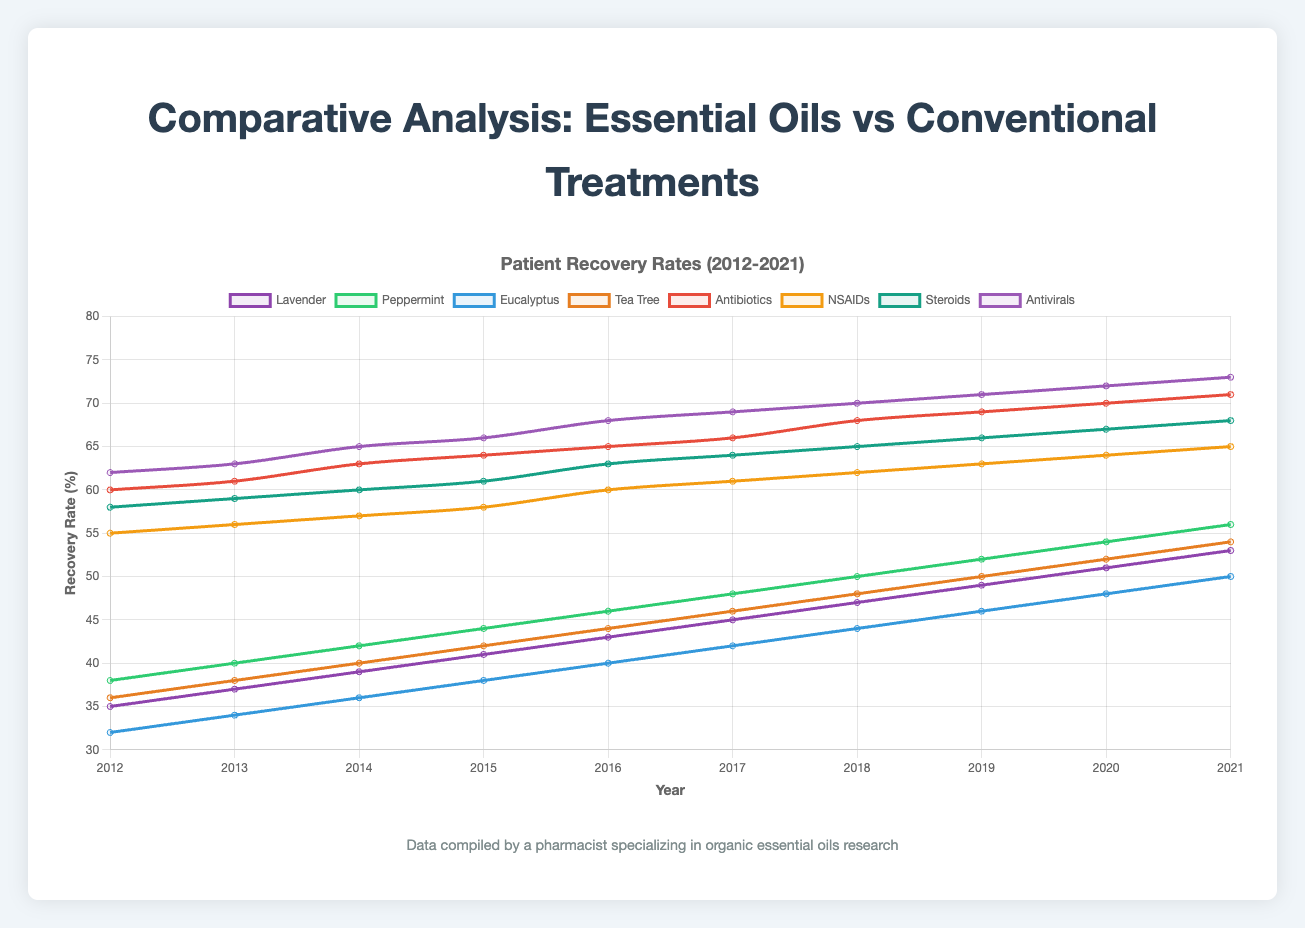Which essential oil showed the highest recovery rate in 2021? By examining the last year in the chart, we can see the data points for each essential oil. Lavender, Peppermint, Eucalyptus, and Tea Tree have recovery rates of 53%, 56%, 50%, and 54%, respectively. Hence, Peppermint had the highest recovery rate.
Answer: Peppermint How did the recovery rate of Tea Tree oil compare to Steroids in 2018? Looking at the 2018 points for Tea Tree oil and Steroids, Tea Tree had a recovery rate of 48% and Steroids had a recovery rate of 65%. Thus, Steroids had a higher recovery rate.
Answer: Steroids had a higher recovery rate What was the average recovery rate of conventional treatments in 2015? Sum the recovery rates of all conventional treatments in 2015: (64 + 58 + 61 + 66) = 249. Then divide by 4 to get the average: 249 / 4 = 62.25.
Answer: 62.25% Which treatment method had the highest rate of increase in recovery rates from 2012 to 2021? Calculate the differences in recovery rates between 2021 and 2012 for each treatment. The highest difference will indicate the treatment with the highest rate of increase. For Antibiotics: 71 - 60 = 11, NSAIDs: 65 - 55 = 10, Steroids: 68 - 58 = 10, Antivirals: 73 - 62 = 11. For essential oils: Lavender: 53 - 35 = 18, Peppermint: 56 - 38 = 18, Eucalyptus: 50 - 32 = 18, Tea Tree: 54 - 36 = 18. All essential oils had the same highest increase.
Answer: Essential Oils What was the combined recovery rate of Peppermint and Antivirals in 2017? Add the recovery rates of Peppermint and Antivirals in 2017: 48% + 69% = 117%.
Answer: 117% In which year did Tea Tree oil first surpassed 40% recovery rate? Analyze the data points for Tea Tree oil. The first year Tea Tree surpasses 40% is in 2014 with a recovery rate of 42%.
Answer: 2014 Which essential oil had the smallest increase in recovery rate from 2012 to 2021? Calculate the change in recovery rate for each essential oil from 2012 to 2021: Lavender: 53 - 35 = 18, Peppermint: 56 - 38 = 18, Eucalyptus: 50 - 32 = 18, Tea Tree: 54 - 36 = 18. All essential oils had the same increase.
Answer: All had the same increase Which recovery rate among conventional treatments showed the best performance in 2020? Look at the 2020 data points for conventional treatments: Antibiotics: 70%, NSAIDs: 64%, Steroids: 67%, Antivirals: 72%. Antivirals had the highest recovery rate in 2020.
Answer: Antivirals How much did the recovery rate of Eucalyptus oil improve from 2013 to 2019? Subtract the recovery rate of Eucalyptus in 2013 from that in 2019: 46% - 34% = 12%.
Answer: 12% Compare the total recovery rate of all essential oils in 2016 to all conventional treatments in the same year. Add up recovery rates for all essential oils: Lavender (43), Peppermint (46), Eucalyptus (40), Tea Tree (44) which equals 173. For conventional treatments: Antibiotics (65), NSAIDs (60), Steroids (63), Antivirals (68) which equals 256. Then compare 173 to 256.
Answer: Conventional treatments had a higher total recovery rate 